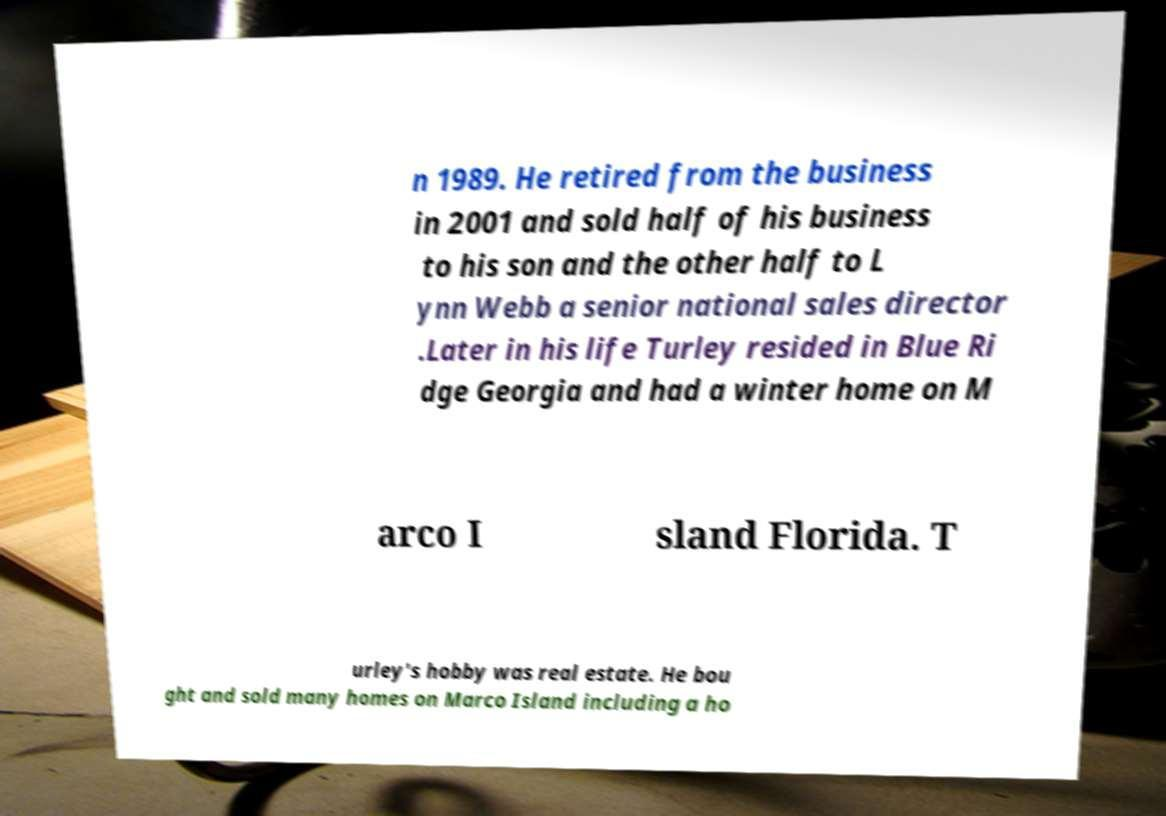What messages or text are displayed in this image? I need them in a readable, typed format. n 1989. He retired from the business in 2001 and sold half of his business to his son and the other half to L ynn Webb a senior national sales director .Later in his life Turley resided in Blue Ri dge Georgia and had a winter home on M arco I sland Florida. T urley's hobby was real estate. He bou ght and sold many homes on Marco Island including a ho 